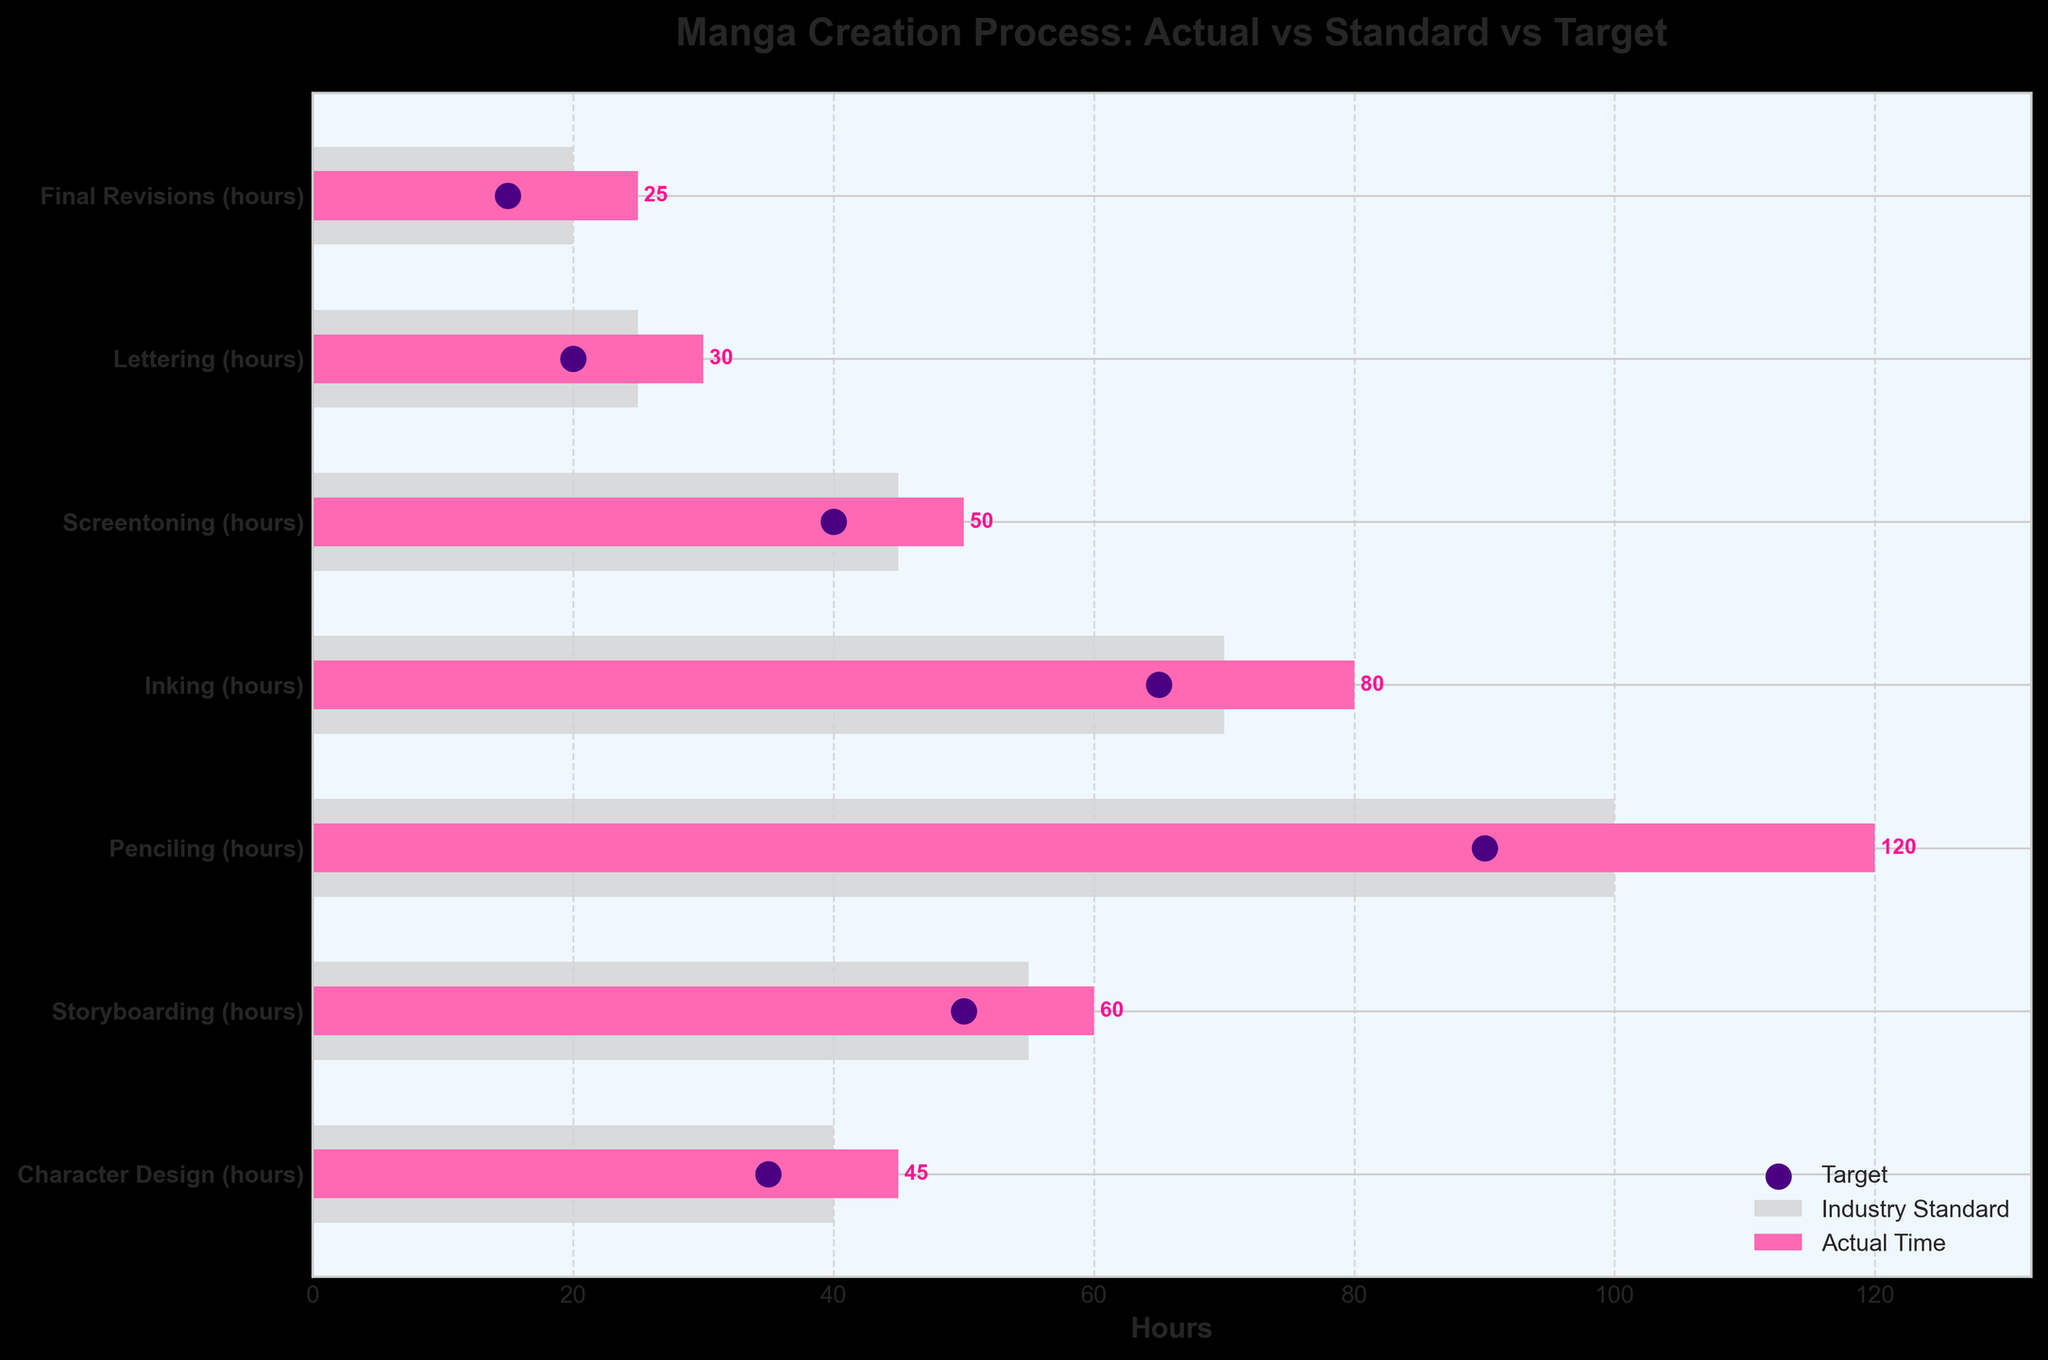How many stages of manga creation are shown in the figure? Count the different stages listed on the y-axis labels.
Answer: 7 What is the title of the chart? Read the main title at the top of the figure.
Answer: Manga Creation Process: Actual vs Standard vs Target What is the standard time spent on storyboarding? Refer to the 'Industry Standard' bar length corresponding to the "Storyboarding (hours)" label.
Answer: 55 hours Which stage has the highest actual time spent? Compare the lengths of the 'Actual Time' bars and find the longest one.
Answer: Penciling (120 hours) How much more time is spent on inking than the target time for inking? Subtract the target time for inking from the actual time spent on inking.
Answer: 80 - 65 = 15 hours Which stage shows the smallest difference between actual time and standard time? Compare the differences between actual time and standard time for each stage and identify the smallest one.
Answer: Lettering (5 hours difference) For which stages does the actual time exceed both the standard and target times? Identify all stages where the actual time is greater than both the standard and target times.
Answer: Character Design, Storyboarding, Penciling, Inking, Screentoning What is the average target time across all stages? Sum the target times for all stages and divide by the number of stages (7).
Answer: (35 + 50 + 90 + 65 + 40 + 20 + 15) / 7 = 315 / 7 = 45 hours Is the actual time spent on final revisions within industry standards? Compare the actual time spent on final revisions to the standard time and see if it's less than or equal.
Answer: No 